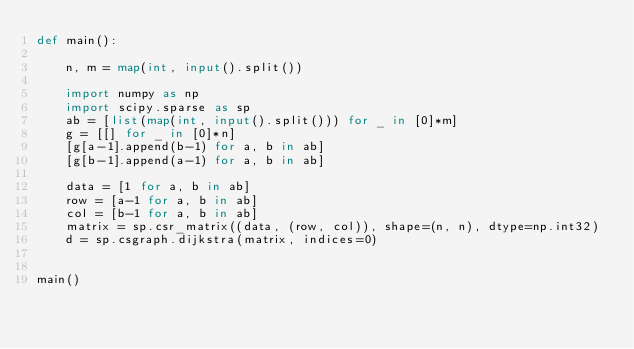Convert code to text. <code><loc_0><loc_0><loc_500><loc_500><_Python_>def main():

    n, m = map(int, input().split())

    import numpy as np
    import scipy.sparse as sp
    ab = [list(map(int, input().split())) for _ in [0]*m]
    g = [[] for _ in [0]*n]
    [g[a-1].append(b-1) for a, b in ab]
    [g[b-1].append(a-1) for a, b in ab]

    data = [1 for a, b in ab]
    row = [a-1 for a, b in ab]
    col = [b-1 for a, b in ab]
    matrix = sp.csr_matrix((data, (row, col)), shape=(n, n), dtype=np.int32)
    d = sp.csgraph.dijkstra(matrix, indices=0)


main()
</code> 